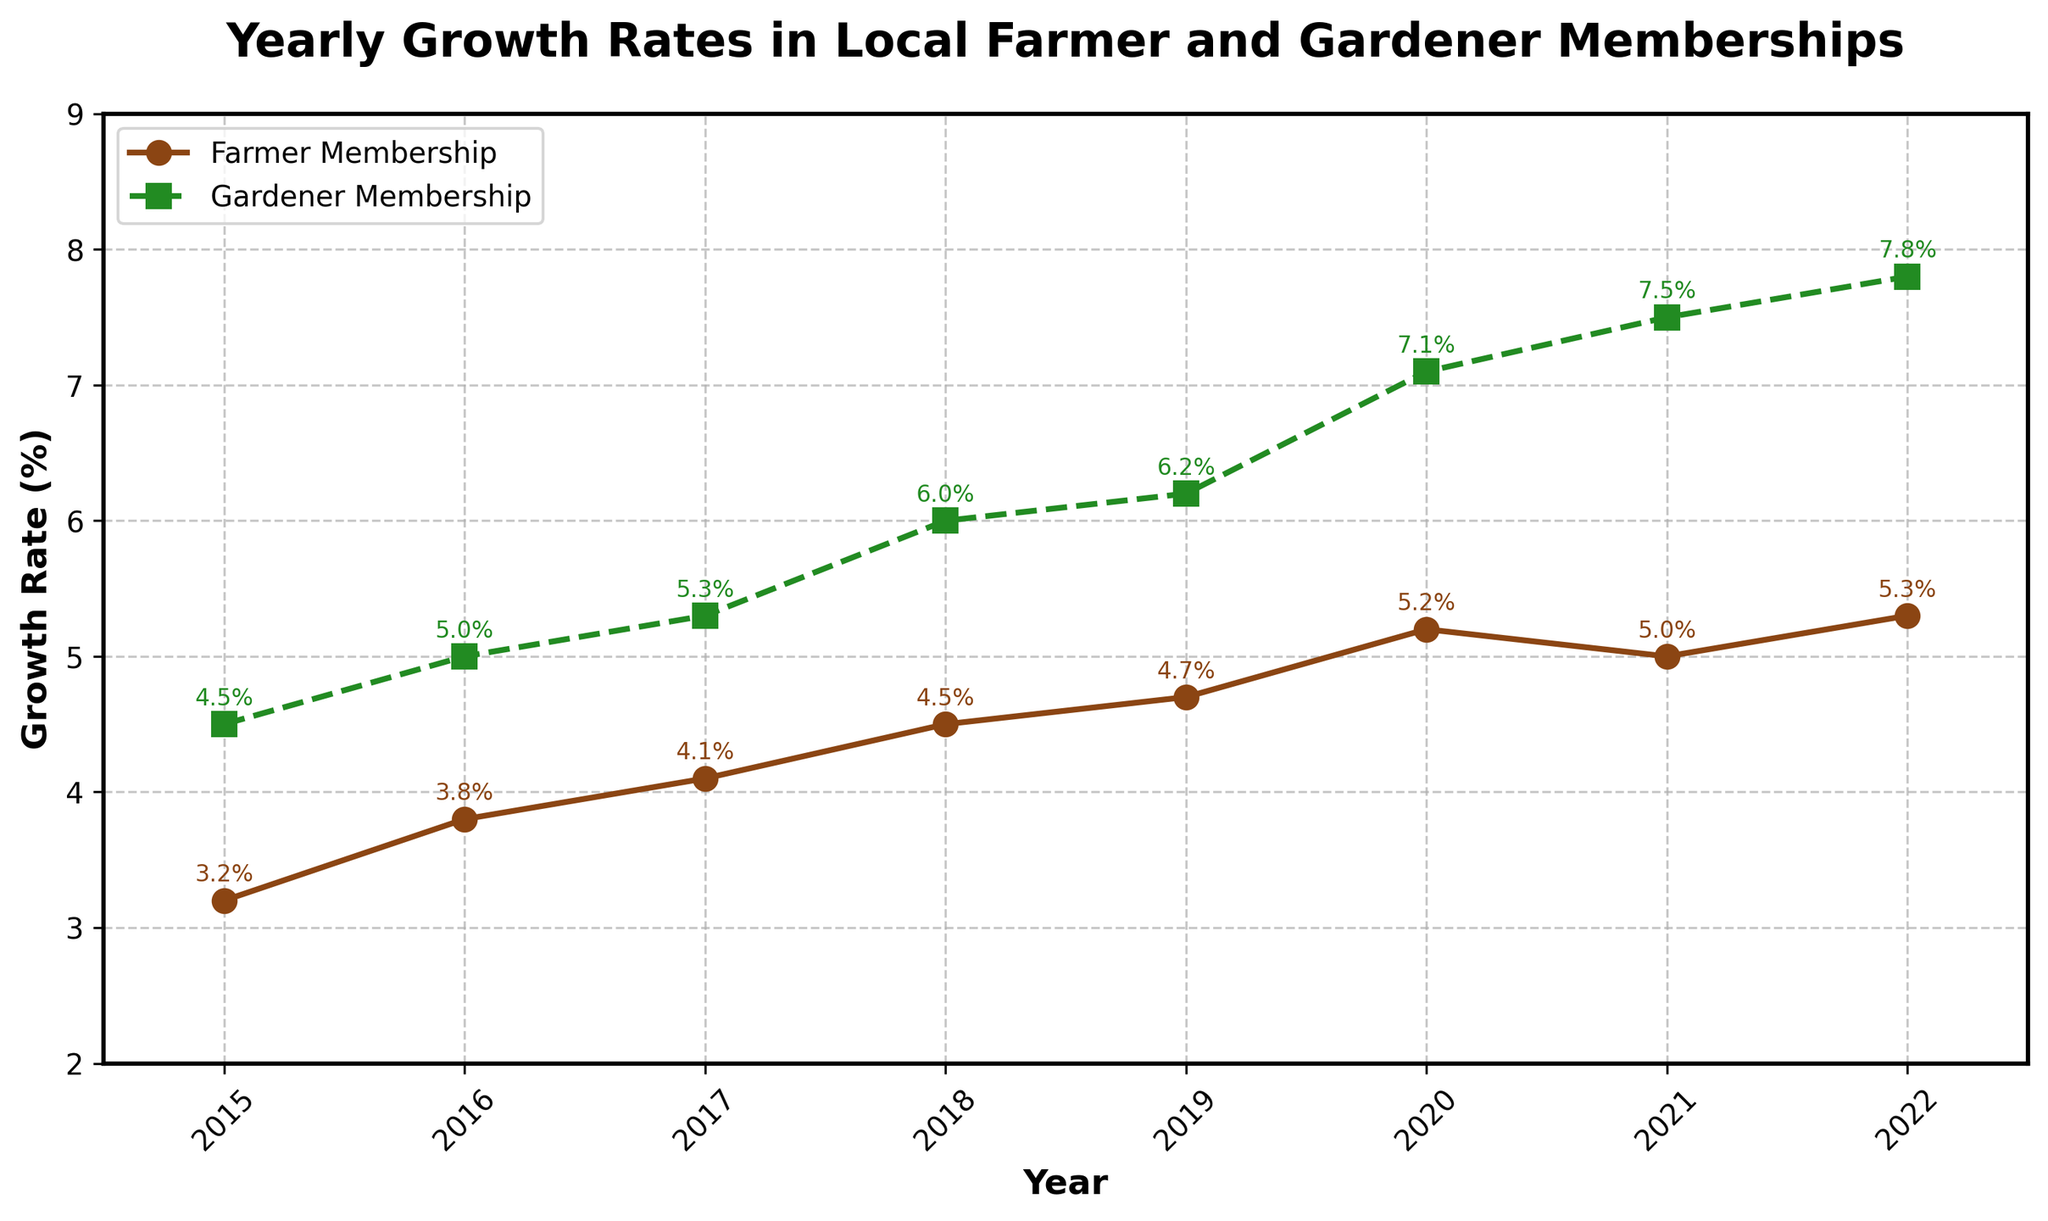What is the title of the figure? At the top of the figure, the title reads "Yearly Growth Rates in Local Farmer and Gardener Memberships".
Answer: Yearly Growth Rates in Local Farmer and Gardener Memberships Which membership type had the higher growth rate in 2020? From the figure, the gardener membership had a higher growth rate in 2020, represented by a green-square marker.
Answer: Gardener Membership What is the growth rate of farmer membership in 2022? By locating the data point for 2022 on the farmer membership line (brown circles), the growth rate is labeled as 5.3%.
Answer: 5.3% From 2017 to 2018, how much did the gardener membership growth rate increase? The gardener growth rate for 2017 is 5.3%, and for 2018 it is 6.0%. The difference is calculated as 6.0% - 5.3% = 0.7%.
Answer: 0.7% Which year had the smallest increase in gardener membership growth rate compared to the previous year? Comparing each year's gardener growth rate to the previous year, the smallest increase is between 2021 (7.5%) and 2022 (7.8%), which is 0.3%.
Answer: 2022 In which year did both farmer and gardener memberships experience their highest growth rates? The highest growth rates for both memberships are in 2022, with farmers at 5.3% and gardeners at 7.8%.
Answer: 2022 What is the average growth rate for farmer membership from 2015 to 2022? The total growth rates are: 3.2 + 3.8 + 4.1 + 4.5 + 4.7 + 5.2 + 5.0 + 5.3 = 35.8. Average = 35.8 / 8 years = 4.475%.
Answer: 4.475% Which year shows a decreasing growth rate for farmer membership? The only year showing a decrease is from 2020 to 2021, where the rate drops from 5.2% to 5.0%.
Answer: 2021 By what percentage did the gardener membership growth rate increase from 2015 to 2022? The gardener growth rate in 2015 was 4.5% and in 2022 it was 7.8%. The increase is 7.8% - 4.5% = 3.3%.
Answer: 3.3% Between farmers and gardeners, which group's membership generally had higher growth rates? Observing the plot, gardener memberships (green squares) consistently had higher growth rates compared to farmer memberships (brown circles).
Answer: Gardener Memberships 